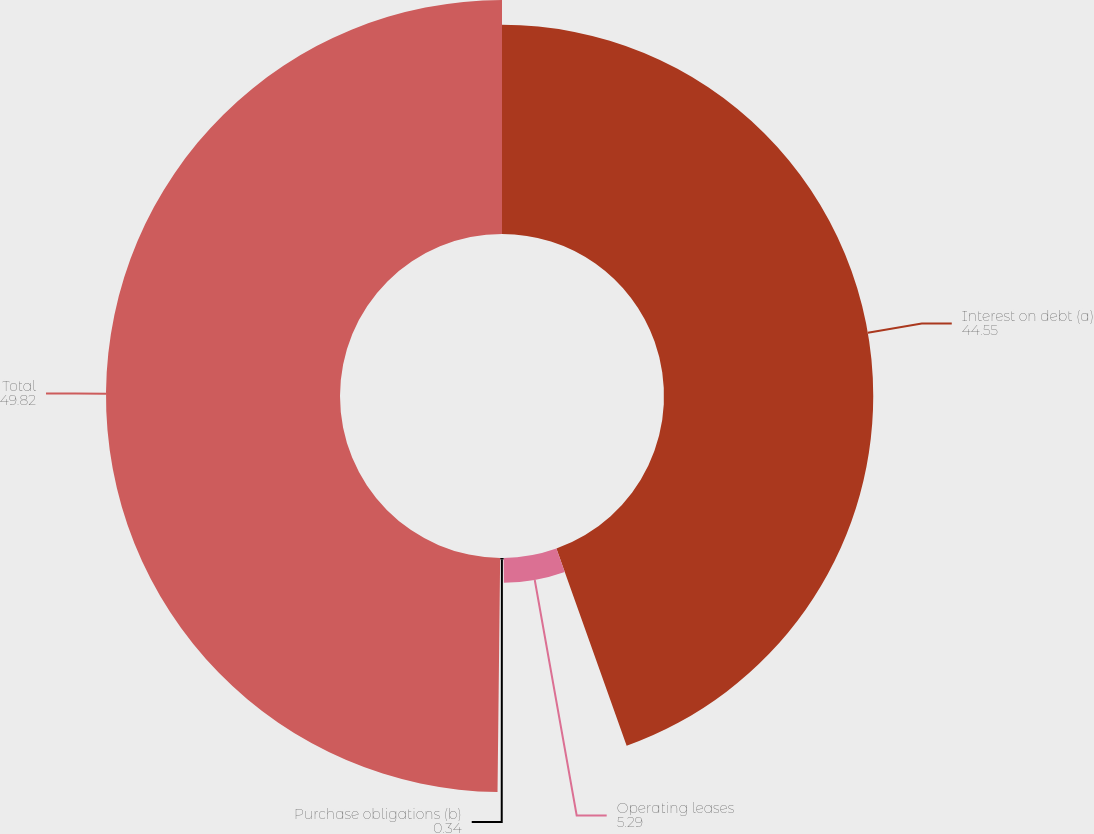<chart> <loc_0><loc_0><loc_500><loc_500><pie_chart><fcel>Interest on debt (a)<fcel>Operating leases<fcel>Purchase obligations (b)<fcel>Total<nl><fcel>44.55%<fcel>5.29%<fcel>0.34%<fcel>49.82%<nl></chart> 